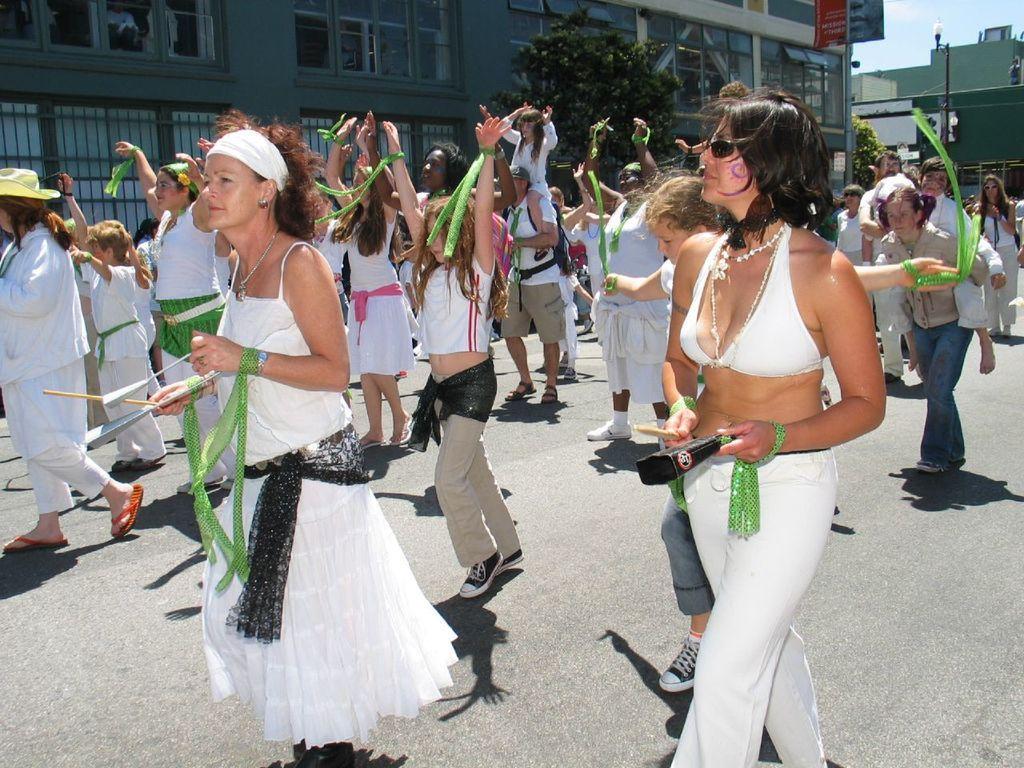What can be observed about the people in the image? There are people standing in the image, and they are wearing different costumes. What are the people holding in the image? The people are holding something, but the specific object cannot be determined from the facts provided. What can be seen in the background of the image? There are buildings, windows, trees, and a light pole visible in the background. What type of silk is draped over the map in the image? There is no map or silk present in the image. What angle is the light pole positioned at in the image? The facts provided do not give any information about the angle of the light pole in the image. 